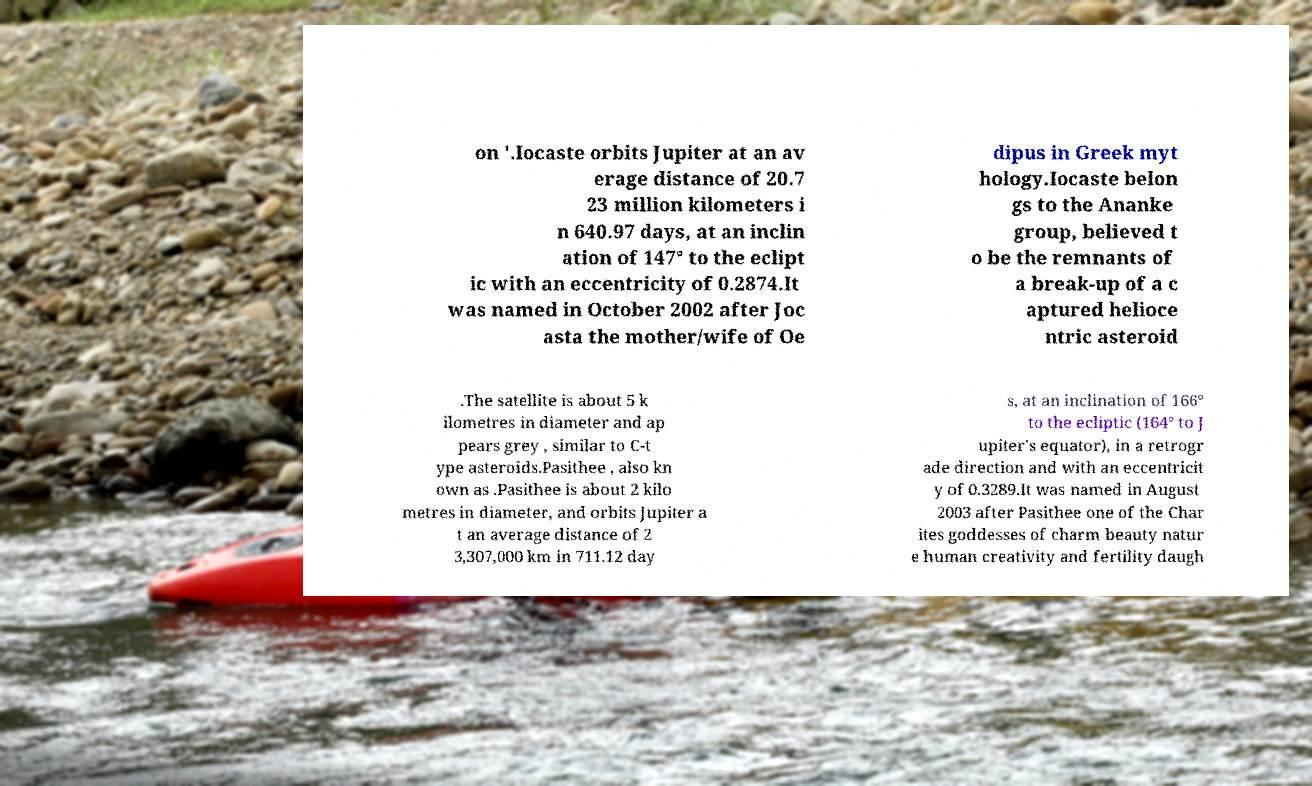Could you assist in decoding the text presented in this image and type it out clearly? on '.Iocaste orbits Jupiter at an av erage distance of 20.7 23 million kilometers i n 640.97 days, at an inclin ation of 147° to the eclipt ic with an eccentricity of 0.2874.It was named in October 2002 after Joc asta the mother/wife of Oe dipus in Greek myt hology.Iocaste belon gs to the Ananke group, believed t o be the remnants of a break-up of a c aptured helioce ntric asteroid .The satellite is about 5 k ilometres in diameter and ap pears grey , similar to C-t ype asteroids.Pasithee , also kn own as .Pasithee is about 2 kilo metres in diameter, and orbits Jupiter a t an average distance of 2 3,307,000 km in 711.12 day s, at an inclination of 166° to the ecliptic (164° to J upiter's equator), in a retrogr ade direction and with an eccentricit y of 0.3289.It was named in August 2003 after Pasithee one of the Char ites goddesses of charm beauty natur e human creativity and fertility daugh 